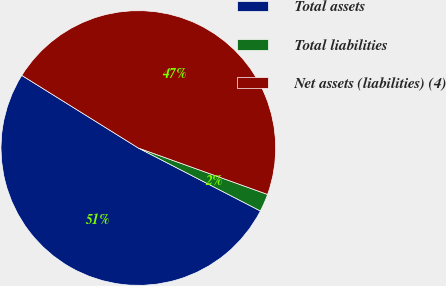Convert chart to OTSL. <chart><loc_0><loc_0><loc_500><loc_500><pie_chart><fcel>Total assets<fcel>Total liabilities<fcel>Net assets (liabilities) (4)<nl><fcel>51.29%<fcel>2.09%<fcel>46.62%<nl></chart> 